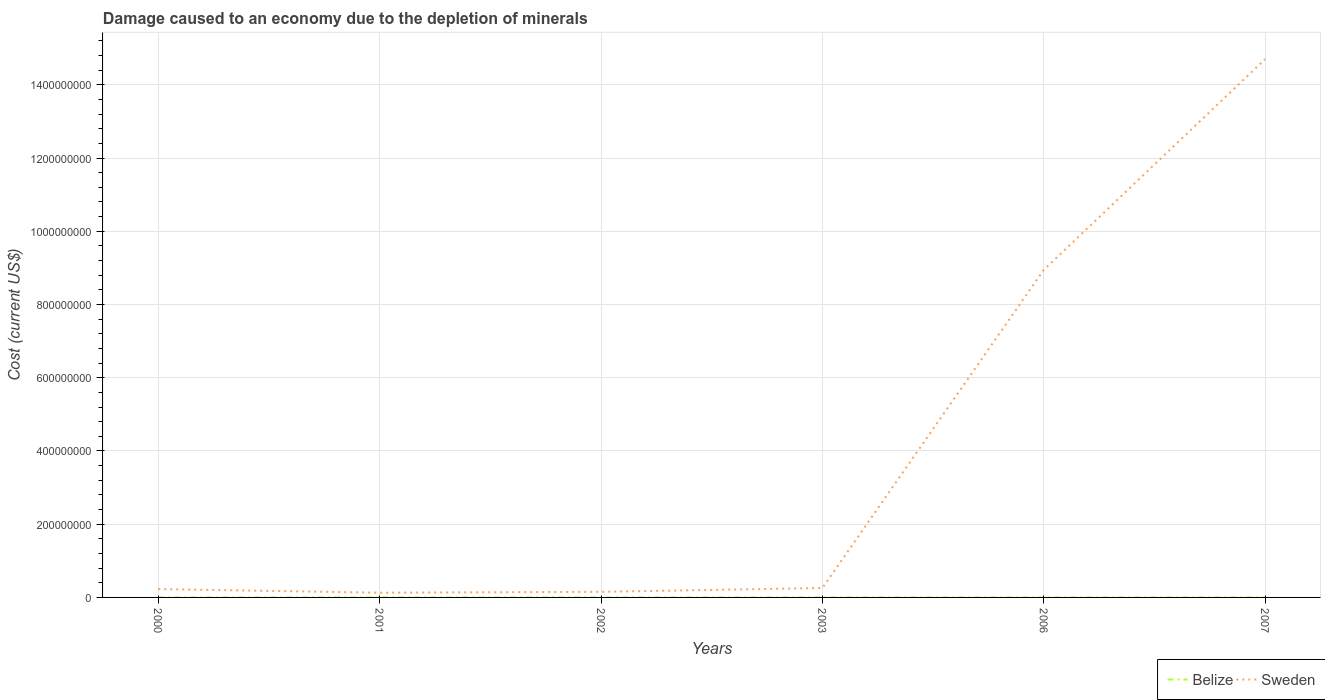Is the number of lines equal to the number of legend labels?
Your response must be concise. Yes. Across all years, what is the maximum cost of damage caused due to the depletion of minerals in Sweden?
Provide a succinct answer. 1.28e+07. What is the total cost of damage caused due to the depletion of minerals in Sweden in the graph?
Keep it short and to the point. -1.04e+07. What is the difference between the highest and the second highest cost of damage caused due to the depletion of minerals in Belize?
Offer a terse response. 2.62e+04. What is the difference between the highest and the lowest cost of damage caused due to the depletion of minerals in Sweden?
Offer a terse response. 2. Is the cost of damage caused due to the depletion of minerals in Belize strictly greater than the cost of damage caused due to the depletion of minerals in Sweden over the years?
Provide a short and direct response. Yes. How many lines are there?
Keep it short and to the point. 2. Are the values on the major ticks of Y-axis written in scientific E-notation?
Keep it short and to the point. No. Does the graph contain any zero values?
Offer a very short reply. No. Where does the legend appear in the graph?
Give a very brief answer. Bottom right. What is the title of the graph?
Make the answer very short. Damage caused to an economy due to the depletion of minerals. What is the label or title of the X-axis?
Your answer should be compact. Years. What is the label or title of the Y-axis?
Ensure brevity in your answer.  Cost (current US$). What is the Cost (current US$) of Belize in 2000?
Your response must be concise. 573.17. What is the Cost (current US$) in Sweden in 2000?
Make the answer very short. 2.29e+07. What is the Cost (current US$) of Belize in 2001?
Your response must be concise. 126.73. What is the Cost (current US$) of Sweden in 2001?
Give a very brief answer. 1.28e+07. What is the Cost (current US$) of Belize in 2002?
Offer a very short reply. 1479.97. What is the Cost (current US$) of Sweden in 2002?
Make the answer very short. 1.53e+07. What is the Cost (current US$) of Belize in 2003?
Ensure brevity in your answer.  1960.29. What is the Cost (current US$) in Sweden in 2003?
Ensure brevity in your answer.  2.57e+07. What is the Cost (current US$) in Belize in 2006?
Keep it short and to the point. 2.10e+04. What is the Cost (current US$) in Sweden in 2006?
Keep it short and to the point. 8.95e+08. What is the Cost (current US$) in Belize in 2007?
Offer a very short reply. 2.63e+04. What is the Cost (current US$) of Sweden in 2007?
Provide a succinct answer. 1.47e+09. Across all years, what is the maximum Cost (current US$) in Belize?
Give a very brief answer. 2.63e+04. Across all years, what is the maximum Cost (current US$) in Sweden?
Your answer should be very brief. 1.47e+09. Across all years, what is the minimum Cost (current US$) in Belize?
Your response must be concise. 126.73. Across all years, what is the minimum Cost (current US$) in Sweden?
Make the answer very short. 1.28e+07. What is the total Cost (current US$) of Belize in the graph?
Your answer should be very brief. 5.15e+04. What is the total Cost (current US$) of Sweden in the graph?
Your response must be concise. 2.44e+09. What is the difference between the Cost (current US$) of Belize in 2000 and that in 2001?
Provide a short and direct response. 446.44. What is the difference between the Cost (current US$) of Sweden in 2000 and that in 2001?
Your response must be concise. 1.01e+07. What is the difference between the Cost (current US$) of Belize in 2000 and that in 2002?
Your answer should be very brief. -906.8. What is the difference between the Cost (current US$) of Sweden in 2000 and that in 2002?
Your answer should be very brief. 7.57e+06. What is the difference between the Cost (current US$) of Belize in 2000 and that in 2003?
Give a very brief answer. -1387.12. What is the difference between the Cost (current US$) of Sweden in 2000 and that in 2003?
Provide a short and direct response. -2.82e+06. What is the difference between the Cost (current US$) of Belize in 2000 and that in 2006?
Provide a succinct answer. -2.05e+04. What is the difference between the Cost (current US$) of Sweden in 2000 and that in 2006?
Your answer should be compact. -8.72e+08. What is the difference between the Cost (current US$) in Belize in 2000 and that in 2007?
Keep it short and to the point. -2.57e+04. What is the difference between the Cost (current US$) of Sweden in 2000 and that in 2007?
Your answer should be very brief. -1.45e+09. What is the difference between the Cost (current US$) of Belize in 2001 and that in 2002?
Offer a terse response. -1353.24. What is the difference between the Cost (current US$) in Sweden in 2001 and that in 2002?
Give a very brief answer. -2.48e+06. What is the difference between the Cost (current US$) in Belize in 2001 and that in 2003?
Ensure brevity in your answer.  -1833.56. What is the difference between the Cost (current US$) of Sweden in 2001 and that in 2003?
Keep it short and to the point. -1.29e+07. What is the difference between the Cost (current US$) in Belize in 2001 and that in 2006?
Your answer should be compact. -2.09e+04. What is the difference between the Cost (current US$) in Sweden in 2001 and that in 2006?
Provide a short and direct response. -8.82e+08. What is the difference between the Cost (current US$) of Belize in 2001 and that in 2007?
Ensure brevity in your answer.  -2.62e+04. What is the difference between the Cost (current US$) of Sweden in 2001 and that in 2007?
Offer a terse response. -1.46e+09. What is the difference between the Cost (current US$) in Belize in 2002 and that in 2003?
Ensure brevity in your answer.  -480.32. What is the difference between the Cost (current US$) in Sweden in 2002 and that in 2003?
Offer a terse response. -1.04e+07. What is the difference between the Cost (current US$) in Belize in 2002 and that in 2006?
Provide a short and direct response. -1.96e+04. What is the difference between the Cost (current US$) of Sweden in 2002 and that in 2006?
Provide a succinct answer. -8.79e+08. What is the difference between the Cost (current US$) of Belize in 2002 and that in 2007?
Your answer should be very brief. -2.48e+04. What is the difference between the Cost (current US$) in Sweden in 2002 and that in 2007?
Offer a very short reply. -1.45e+09. What is the difference between the Cost (current US$) of Belize in 2003 and that in 2006?
Keep it short and to the point. -1.91e+04. What is the difference between the Cost (current US$) in Sweden in 2003 and that in 2006?
Your response must be concise. -8.69e+08. What is the difference between the Cost (current US$) in Belize in 2003 and that in 2007?
Offer a very short reply. -2.43e+04. What is the difference between the Cost (current US$) in Sweden in 2003 and that in 2007?
Keep it short and to the point. -1.44e+09. What is the difference between the Cost (current US$) in Belize in 2006 and that in 2007?
Your response must be concise. -5266.77. What is the difference between the Cost (current US$) in Sweden in 2006 and that in 2007?
Ensure brevity in your answer.  -5.75e+08. What is the difference between the Cost (current US$) in Belize in 2000 and the Cost (current US$) in Sweden in 2001?
Make the answer very short. -1.28e+07. What is the difference between the Cost (current US$) in Belize in 2000 and the Cost (current US$) in Sweden in 2002?
Ensure brevity in your answer.  -1.53e+07. What is the difference between the Cost (current US$) in Belize in 2000 and the Cost (current US$) in Sweden in 2003?
Your response must be concise. -2.57e+07. What is the difference between the Cost (current US$) in Belize in 2000 and the Cost (current US$) in Sweden in 2006?
Ensure brevity in your answer.  -8.95e+08. What is the difference between the Cost (current US$) in Belize in 2000 and the Cost (current US$) in Sweden in 2007?
Make the answer very short. -1.47e+09. What is the difference between the Cost (current US$) of Belize in 2001 and the Cost (current US$) of Sweden in 2002?
Give a very brief answer. -1.53e+07. What is the difference between the Cost (current US$) in Belize in 2001 and the Cost (current US$) in Sweden in 2003?
Provide a short and direct response. -2.57e+07. What is the difference between the Cost (current US$) of Belize in 2001 and the Cost (current US$) of Sweden in 2006?
Your response must be concise. -8.95e+08. What is the difference between the Cost (current US$) of Belize in 2001 and the Cost (current US$) of Sweden in 2007?
Offer a terse response. -1.47e+09. What is the difference between the Cost (current US$) of Belize in 2002 and the Cost (current US$) of Sweden in 2003?
Ensure brevity in your answer.  -2.57e+07. What is the difference between the Cost (current US$) in Belize in 2002 and the Cost (current US$) in Sweden in 2006?
Give a very brief answer. -8.95e+08. What is the difference between the Cost (current US$) of Belize in 2002 and the Cost (current US$) of Sweden in 2007?
Give a very brief answer. -1.47e+09. What is the difference between the Cost (current US$) in Belize in 2003 and the Cost (current US$) in Sweden in 2006?
Keep it short and to the point. -8.95e+08. What is the difference between the Cost (current US$) in Belize in 2003 and the Cost (current US$) in Sweden in 2007?
Give a very brief answer. -1.47e+09. What is the difference between the Cost (current US$) of Belize in 2006 and the Cost (current US$) of Sweden in 2007?
Make the answer very short. -1.47e+09. What is the average Cost (current US$) of Belize per year?
Make the answer very short. 8580.35. What is the average Cost (current US$) of Sweden per year?
Your answer should be very brief. 4.07e+08. In the year 2000, what is the difference between the Cost (current US$) in Belize and Cost (current US$) in Sweden?
Provide a succinct answer. -2.29e+07. In the year 2001, what is the difference between the Cost (current US$) in Belize and Cost (current US$) in Sweden?
Give a very brief answer. -1.28e+07. In the year 2002, what is the difference between the Cost (current US$) in Belize and Cost (current US$) in Sweden?
Give a very brief answer. -1.53e+07. In the year 2003, what is the difference between the Cost (current US$) in Belize and Cost (current US$) in Sweden?
Your response must be concise. -2.57e+07. In the year 2006, what is the difference between the Cost (current US$) of Belize and Cost (current US$) of Sweden?
Ensure brevity in your answer.  -8.95e+08. In the year 2007, what is the difference between the Cost (current US$) in Belize and Cost (current US$) in Sweden?
Your answer should be very brief. -1.47e+09. What is the ratio of the Cost (current US$) of Belize in 2000 to that in 2001?
Your answer should be very brief. 4.52. What is the ratio of the Cost (current US$) of Sweden in 2000 to that in 2001?
Your answer should be compact. 1.78. What is the ratio of the Cost (current US$) of Belize in 2000 to that in 2002?
Your answer should be compact. 0.39. What is the ratio of the Cost (current US$) in Sweden in 2000 to that in 2002?
Your response must be concise. 1.49. What is the ratio of the Cost (current US$) of Belize in 2000 to that in 2003?
Provide a short and direct response. 0.29. What is the ratio of the Cost (current US$) in Sweden in 2000 to that in 2003?
Ensure brevity in your answer.  0.89. What is the ratio of the Cost (current US$) of Belize in 2000 to that in 2006?
Your answer should be very brief. 0.03. What is the ratio of the Cost (current US$) of Sweden in 2000 to that in 2006?
Ensure brevity in your answer.  0.03. What is the ratio of the Cost (current US$) in Belize in 2000 to that in 2007?
Offer a very short reply. 0.02. What is the ratio of the Cost (current US$) in Sweden in 2000 to that in 2007?
Your response must be concise. 0.02. What is the ratio of the Cost (current US$) of Belize in 2001 to that in 2002?
Your answer should be compact. 0.09. What is the ratio of the Cost (current US$) of Sweden in 2001 to that in 2002?
Provide a succinct answer. 0.84. What is the ratio of the Cost (current US$) of Belize in 2001 to that in 2003?
Offer a terse response. 0.06. What is the ratio of the Cost (current US$) in Sweden in 2001 to that in 2003?
Your answer should be compact. 0.5. What is the ratio of the Cost (current US$) of Belize in 2001 to that in 2006?
Ensure brevity in your answer.  0.01. What is the ratio of the Cost (current US$) of Sweden in 2001 to that in 2006?
Give a very brief answer. 0.01. What is the ratio of the Cost (current US$) in Belize in 2001 to that in 2007?
Your response must be concise. 0. What is the ratio of the Cost (current US$) in Sweden in 2001 to that in 2007?
Offer a very short reply. 0.01. What is the ratio of the Cost (current US$) in Belize in 2002 to that in 2003?
Keep it short and to the point. 0.76. What is the ratio of the Cost (current US$) of Sweden in 2002 to that in 2003?
Provide a succinct answer. 0.6. What is the ratio of the Cost (current US$) of Belize in 2002 to that in 2006?
Your answer should be very brief. 0.07. What is the ratio of the Cost (current US$) of Sweden in 2002 to that in 2006?
Ensure brevity in your answer.  0.02. What is the ratio of the Cost (current US$) of Belize in 2002 to that in 2007?
Your response must be concise. 0.06. What is the ratio of the Cost (current US$) of Sweden in 2002 to that in 2007?
Keep it short and to the point. 0.01. What is the ratio of the Cost (current US$) in Belize in 2003 to that in 2006?
Your answer should be compact. 0.09. What is the ratio of the Cost (current US$) of Sweden in 2003 to that in 2006?
Your answer should be compact. 0.03. What is the ratio of the Cost (current US$) of Belize in 2003 to that in 2007?
Your answer should be compact. 0.07. What is the ratio of the Cost (current US$) in Sweden in 2003 to that in 2007?
Your answer should be compact. 0.02. What is the ratio of the Cost (current US$) in Belize in 2006 to that in 2007?
Keep it short and to the point. 0.8. What is the ratio of the Cost (current US$) of Sweden in 2006 to that in 2007?
Your response must be concise. 0.61. What is the difference between the highest and the second highest Cost (current US$) in Belize?
Provide a succinct answer. 5266.77. What is the difference between the highest and the second highest Cost (current US$) of Sweden?
Your answer should be compact. 5.75e+08. What is the difference between the highest and the lowest Cost (current US$) of Belize?
Give a very brief answer. 2.62e+04. What is the difference between the highest and the lowest Cost (current US$) of Sweden?
Provide a succinct answer. 1.46e+09. 